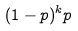Convert formula to latex. <formula><loc_0><loc_0><loc_500><loc_500>( 1 - p ) ^ { k } p</formula> 